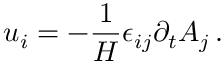Convert formula to latex. <formula><loc_0><loc_0><loc_500><loc_500>u _ { i } = - \frac { 1 } { H } \epsilon _ { i j } \partial _ { t } { A } _ { j } \, .</formula> 